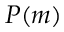<formula> <loc_0><loc_0><loc_500><loc_500>P ( m )</formula> 